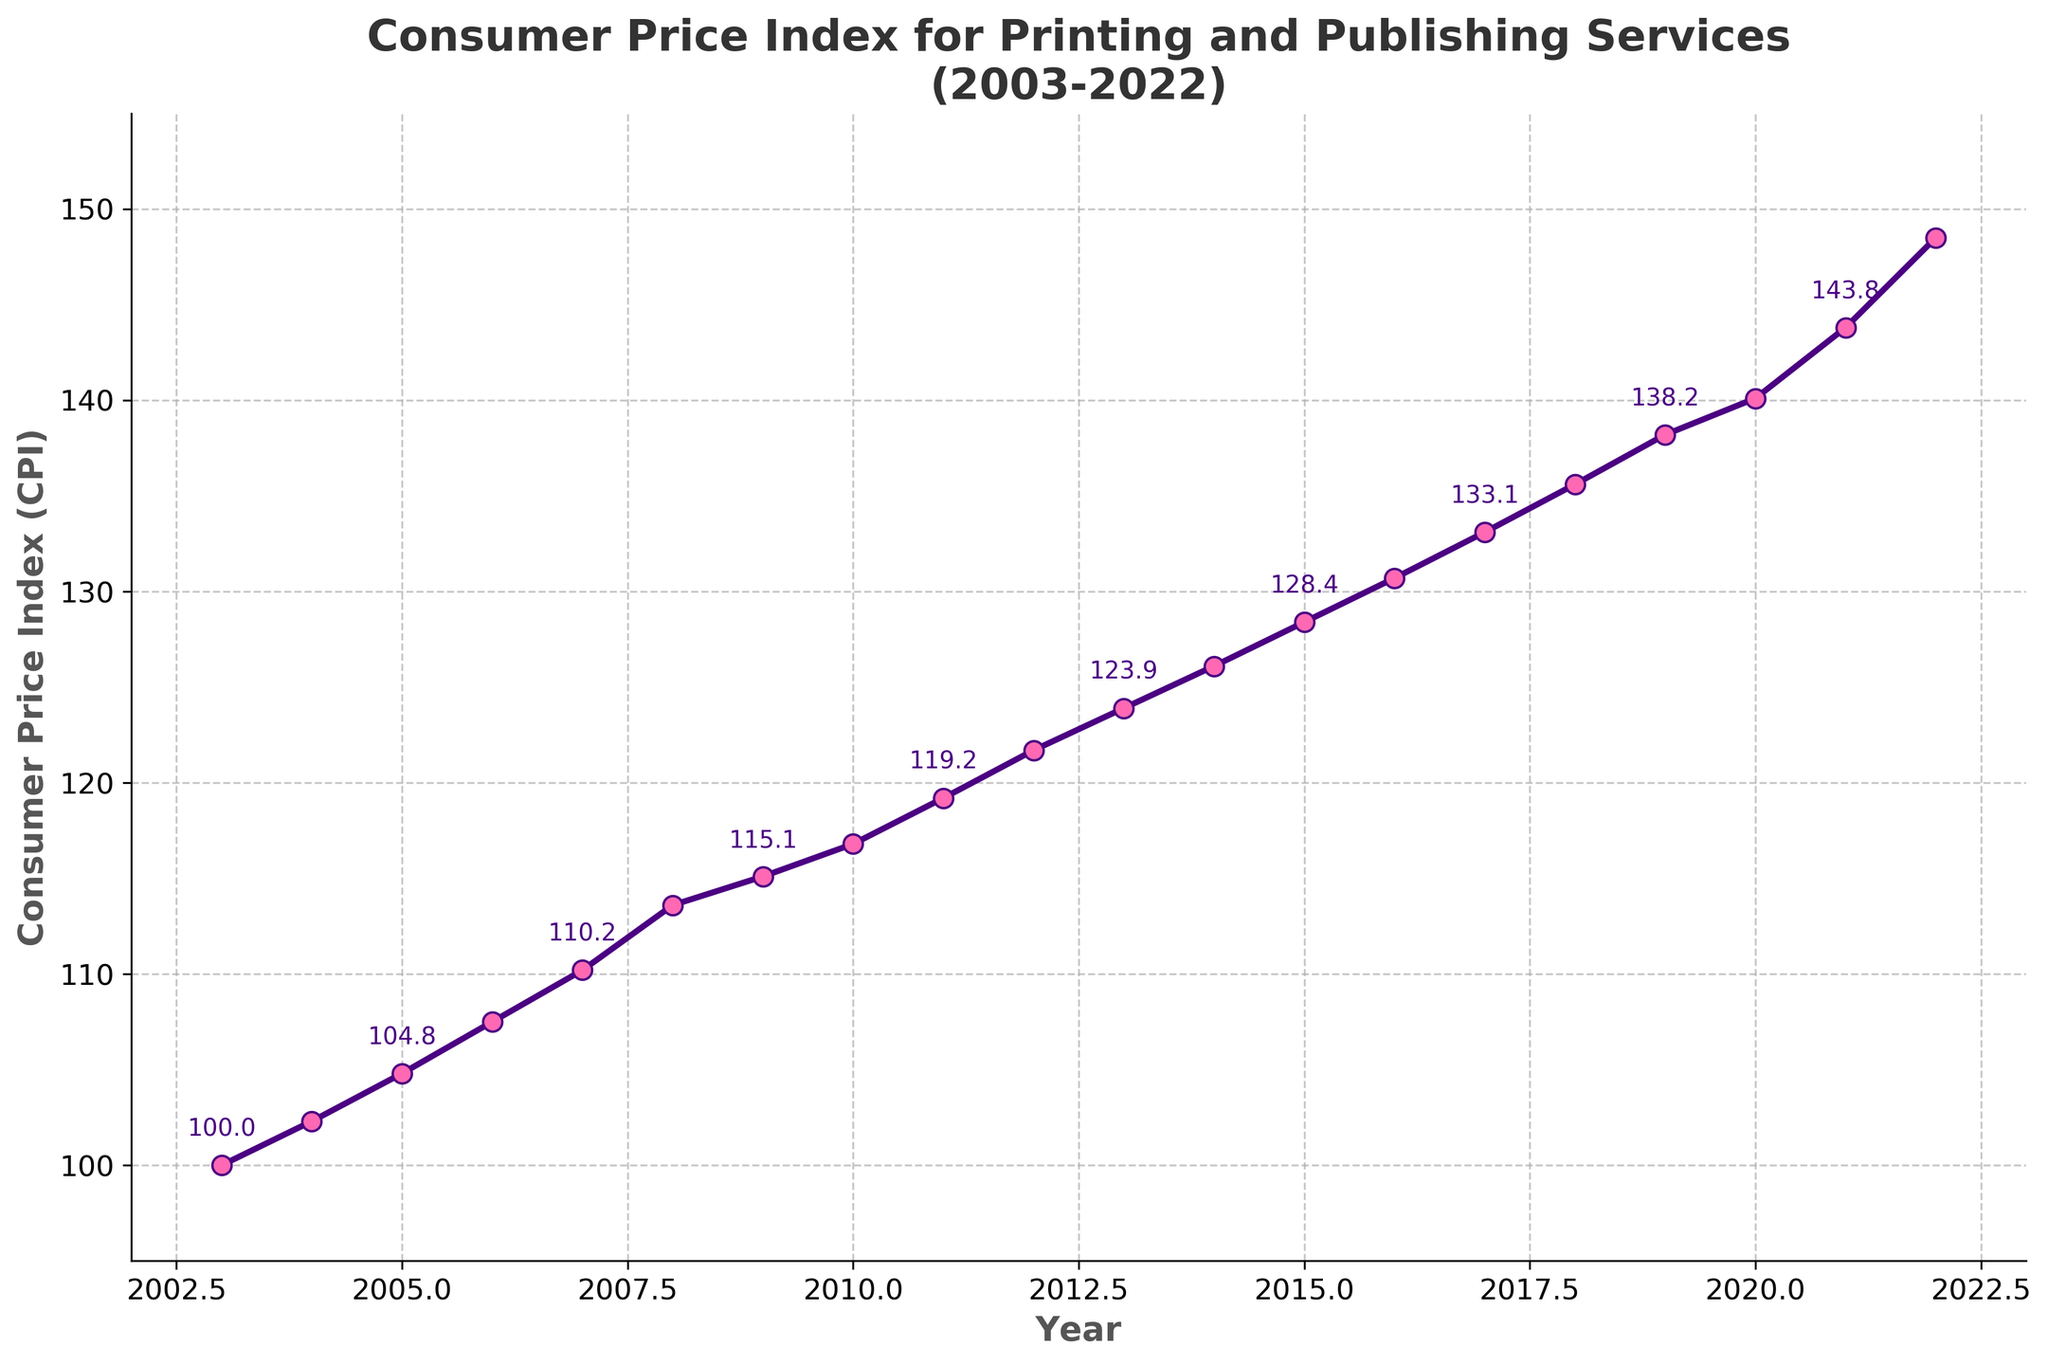What is the CPI for Printing and Publishing Services in 2009? Locate the year 2009 on the x-axis and follow it vertically to the line plot, then track the point horizontally to the y-axis to find the CPI value for that year.
Answer: 115.1 How much did the CPI change from 2003 to 2022? Identify the CPI values for the years 2003 and 2022 from the plot. Subtract the 2003 value from the 2022 value: 148.5 - 100.0 = 48.5.
Answer: 48.5 Which year experienced the largest single-year increase in CPI? Check the differences between consecutive years. The largest increase is between 2021 (143.8) and 2022 (148.5), which is 148.5 - 143.8 = 4.7.
Answer: 2022 Between which consecutive years did the CPI increase by 2.3? Identify the years where the differences between consecutive CPI values equal 2.3. This occurs between 2004 (102.3) and 2005 (104.8).
Answer: 2005 What's the average CPI for the first 10 years (2003-2012)? Sum the CPI values from 2003 to 2012, then divide by the number of years (10): (100 + 102.3 + 104.8 + 107.5 + 110.2 + 113.6 + 115.1 + 116.8 + 119.2 + 121.7) / 10 = 111.12.
Answer: 111.1 Is the CPI value higher in 2015 or in 2018? Locate the CPI values for the years 2015 and 2018 on the plot: 2015 (128.4) and 2018 (135.6). Compare these values.
Answer: 2018 What is the overall trend of the CPI from 2003 to 2022? Observe the plot from 2003 to 2022 and note the general direction of the line. The line consistently moves upwards, indicating an increasing trend.
Answer: Increasing In which year did the CPI first exceed 130? Identify the first year where the CPI value is greater than 130. This occurs in 2016 (130.7).
Answer: 2016 How long did it take for the CPI to increase from 100 to 120? Determine the years when CPI was 100 (2003) and first reached or exceeded 120 (2011). Calculate the difference in years: 2011 - 2003 = 8 years.
Answer: 8 years 